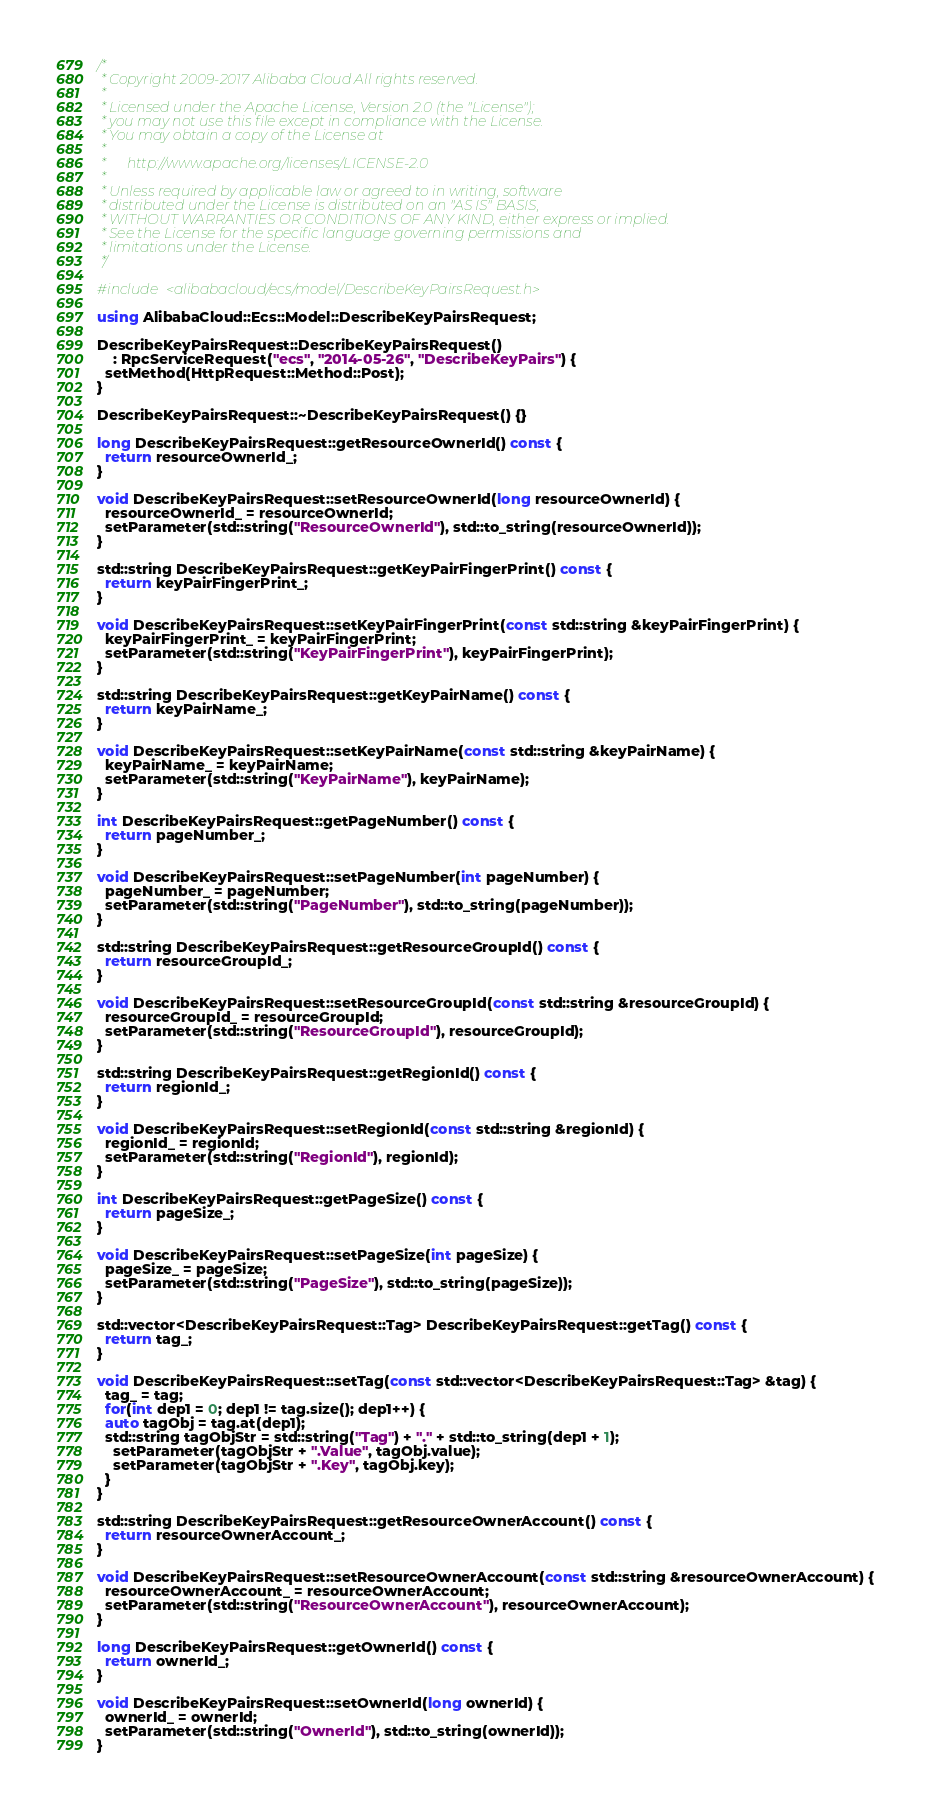<code> <loc_0><loc_0><loc_500><loc_500><_C++_>/*
 * Copyright 2009-2017 Alibaba Cloud All rights reserved.
 *
 * Licensed under the Apache License, Version 2.0 (the "License");
 * you may not use this file except in compliance with the License.
 * You may obtain a copy of the License at
 *
 *      http://www.apache.org/licenses/LICENSE-2.0
 *
 * Unless required by applicable law or agreed to in writing, software
 * distributed under the License is distributed on an "AS IS" BASIS,
 * WITHOUT WARRANTIES OR CONDITIONS OF ANY KIND, either express or implied.
 * See the License for the specific language governing permissions and
 * limitations under the License.
 */

#include <alibabacloud/ecs/model/DescribeKeyPairsRequest.h>

using AlibabaCloud::Ecs::Model::DescribeKeyPairsRequest;

DescribeKeyPairsRequest::DescribeKeyPairsRequest()
    : RpcServiceRequest("ecs", "2014-05-26", "DescribeKeyPairs") {
  setMethod(HttpRequest::Method::Post);
}

DescribeKeyPairsRequest::~DescribeKeyPairsRequest() {}

long DescribeKeyPairsRequest::getResourceOwnerId() const {
  return resourceOwnerId_;
}

void DescribeKeyPairsRequest::setResourceOwnerId(long resourceOwnerId) {
  resourceOwnerId_ = resourceOwnerId;
  setParameter(std::string("ResourceOwnerId"), std::to_string(resourceOwnerId));
}

std::string DescribeKeyPairsRequest::getKeyPairFingerPrint() const {
  return keyPairFingerPrint_;
}

void DescribeKeyPairsRequest::setKeyPairFingerPrint(const std::string &keyPairFingerPrint) {
  keyPairFingerPrint_ = keyPairFingerPrint;
  setParameter(std::string("KeyPairFingerPrint"), keyPairFingerPrint);
}

std::string DescribeKeyPairsRequest::getKeyPairName() const {
  return keyPairName_;
}

void DescribeKeyPairsRequest::setKeyPairName(const std::string &keyPairName) {
  keyPairName_ = keyPairName;
  setParameter(std::string("KeyPairName"), keyPairName);
}

int DescribeKeyPairsRequest::getPageNumber() const {
  return pageNumber_;
}

void DescribeKeyPairsRequest::setPageNumber(int pageNumber) {
  pageNumber_ = pageNumber;
  setParameter(std::string("PageNumber"), std::to_string(pageNumber));
}

std::string DescribeKeyPairsRequest::getResourceGroupId() const {
  return resourceGroupId_;
}

void DescribeKeyPairsRequest::setResourceGroupId(const std::string &resourceGroupId) {
  resourceGroupId_ = resourceGroupId;
  setParameter(std::string("ResourceGroupId"), resourceGroupId);
}

std::string DescribeKeyPairsRequest::getRegionId() const {
  return regionId_;
}

void DescribeKeyPairsRequest::setRegionId(const std::string &regionId) {
  regionId_ = regionId;
  setParameter(std::string("RegionId"), regionId);
}

int DescribeKeyPairsRequest::getPageSize() const {
  return pageSize_;
}

void DescribeKeyPairsRequest::setPageSize(int pageSize) {
  pageSize_ = pageSize;
  setParameter(std::string("PageSize"), std::to_string(pageSize));
}

std::vector<DescribeKeyPairsRequest::Tag> DescribeKeyPairsRequest::getTag() const {
  return tag_;
}

void DescribeKeyPairsRequest::setTag(const std::vector<DescribeKeyPairsRequest::Tag> &tag) {
  tag_ = tag;
  for(int dep1 = 0; dep1 != tag.size(); dep1++) {
  auto tagObj = tag.at(dep1);
  std::string tagObjStr = std::string("Tag") + "." + std::to_string(dep1 + 1);
    setParameter(tagObjStr + ".Value", tagObj.value);
    setParameter(tagObjStr + ".Key", tagObj.key);
  }
}

std::string DescribeKeyPairsRequest::getResourceOwnerAccount() const {
  return resourceOwnerAccount_;
}

void DescribeKeyPairsRequest::setResourceOwnerAccount(const std::string &resourceOwnerAccount) {
  resourceOwnerAccount_ = resourceOwnerAccount;
  setParameter(std::string("ResourceOwnerAccount"), resourceOwnerAccount);
}

long DescribeKeyPairsRequest::getOwnerId() const {
  return ownerId_;
}

void DescribeKeyPairsRequest::setOwnerId(long ownerId) {
  ownerId_ = ownerId;
  setParameter(std::string("OwnerId"), std::to_string(ownerId));
}

</code> 